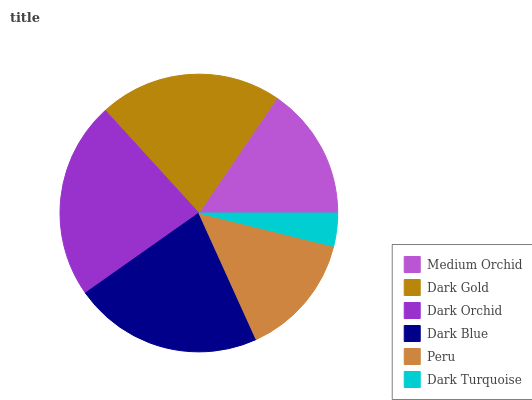Is Dark Turquoise the minimum?
Answer yes or no. Yes. Is Dark Orchid the maximum?
Answer yes or no. Yes. Is Dark Gold the minimum?
Answer yes or no. No. Is Dark Gold the maximum?
Answer yes or no. No. Is Dark Gold greater than Medium Orchid?
Answer yes or no. Yes. Is Medium Orchid less than Dark Gold?
Answer yes or no. Yes. Is Medium Orchid greater than Dark Gold?
Answer yes or no. No. Is Dark Gold less than Medium Orchid?
Answer yes or no. No. Is Dark Gold the high median?
Answer yes or no. Yes. Is Medium Orchid the low median?
Answer yes or no. Yes. Is Dark Orchid the high median?
Answer yes or no. No. Is Peru the low median?
Answer yes or no. No. 